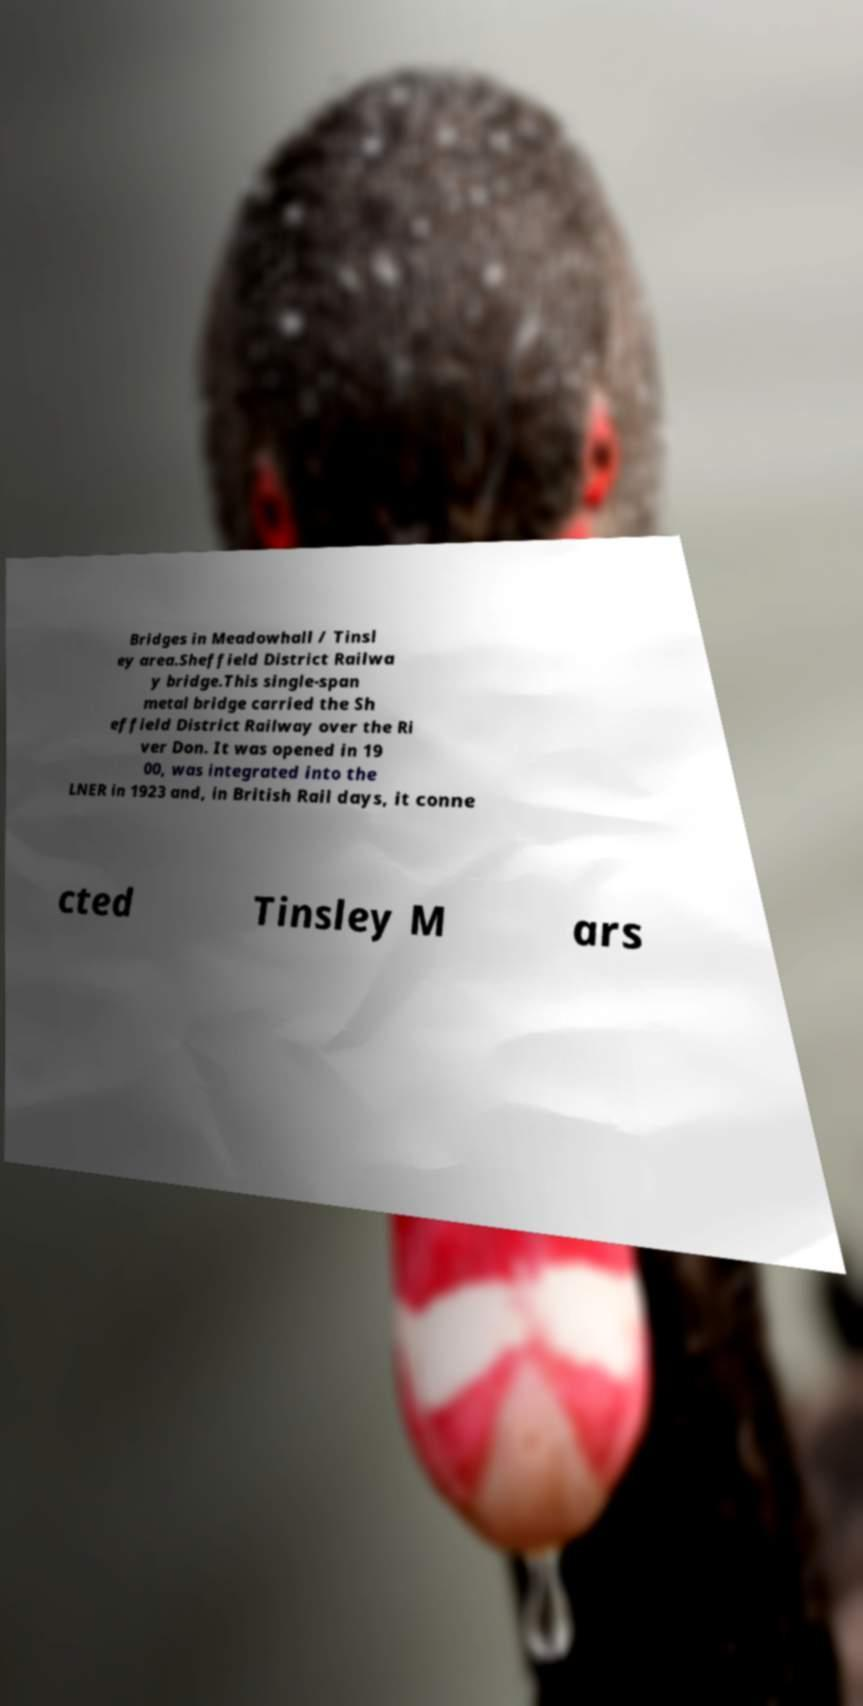Can you accurately transcribe the text from the provided image for me? Bridges in Meadowhall / Tinsl ey area.Sheffield District Railwa y bridge.This single-span metal bridge carried the Sh effield District Railway over the Ri ver Don. It was opened in 19 00, was integrated into the LNER in 1923 and, in British Rail days, it conne cted Tinsley M ars 